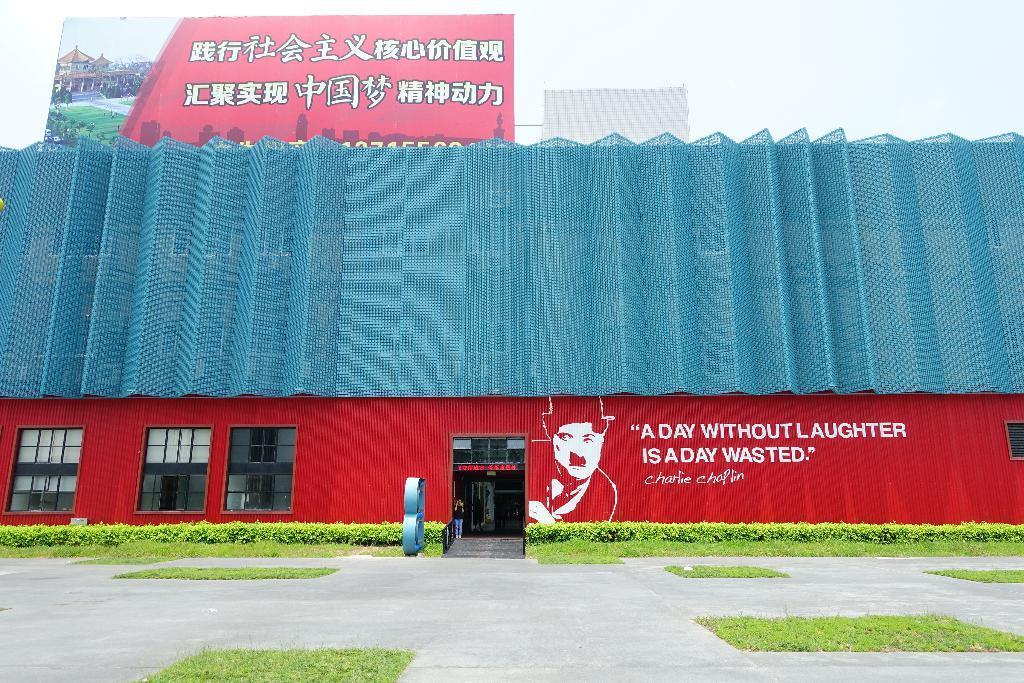How would you summarize this image in a sentence or two? In this picture we can see a building with windows, banner, trees, grass, path and in the background we can see the sky. 